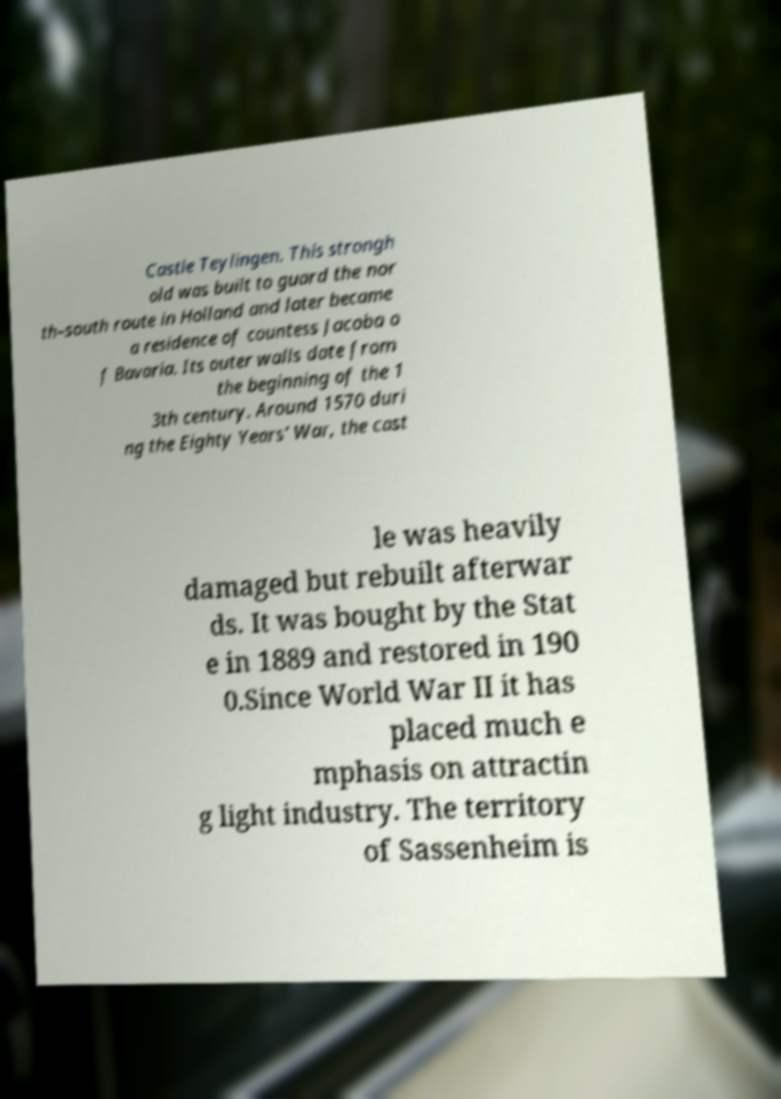Can you read and provide the text displayed in the image?This photo seems to have some interesting text. Can you extract and type it out for me? Castle Teylingen. This strongh old was built to guard the nor th–south route in Holland and later became a residence of countess Jacoba o f Bavaria. Its outer walls date from the beginning of the 1 3th century. Around 1570 duri ng the Eighty Years' War, the cast le was heavily damaged but rebuilt afterwar ds. It was bought by the Stat e in 1889 and restored in 190 0.Since World War II it has placed much e mphasis on attractin g light industry. The territory of Sassenheim is 